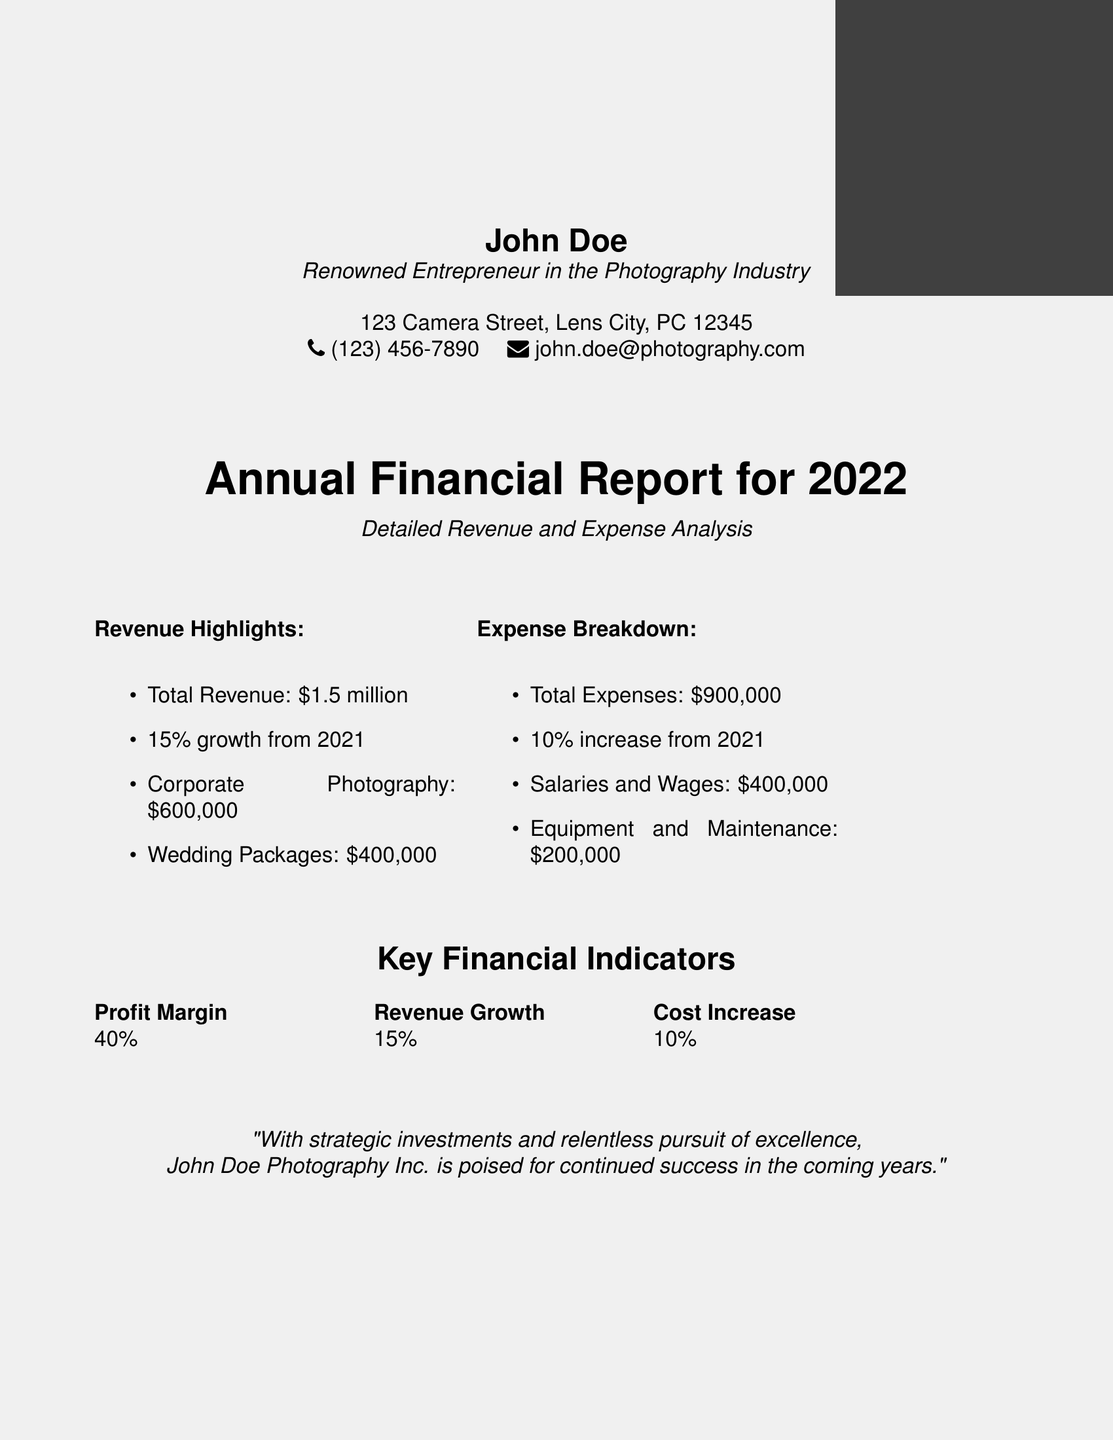what is the total revenue? The total revenue is stated as $1.5 million in the document.
Answer: $1.5 million what is the profit margin? The document lists the profit margin as a key financial indicator.
Answer: 40% how much did corporate photography generate? The document specifies that corporate photography generated $600,000 in revenue.
Answer: $600,000 what percentage increase did expenses have from 2021? The expenses increased by 10% from the previous year, as mentioned in the expense breakdown.
Answer: 10% what is the total amount spent on salaries and wages? The document indicates that salaries and wages totaled $400,000.
Answer: $400,000 how much revenue was generated from wedding packages? The revenue generated from wedding packages is provided in the revenue highlights.
Answer: $400,000 what is the revenue growth percentage for 2022? The revenue growth for 2022 is mentioned as 15%.
Answer: 15% what is the total expenses for the year? The total expenses for the year is shown as $900,000 in the document.
Answer: $900,000 who is the renowned entrepreneur mentioned in the report? The document states that John Doe is the renowned entrepreneur in the photography industry.
Answer: John Doe what does the quote in the document emphasize? The quote implies a commitment to strategic investments and excellence for future success.
Answer: success 